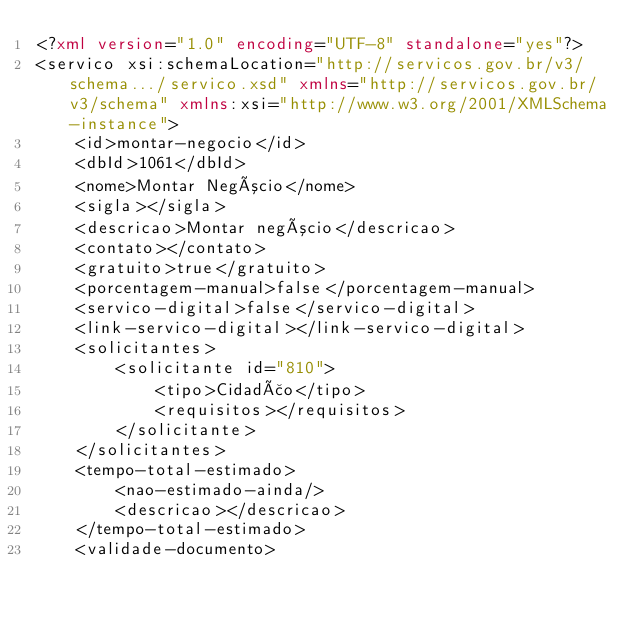<code> <loc_0><loc_0><loc_500><loc_500><_XML_><?xml version="1.0" encoding="UTF-8" standalone="yes"?>
<servico xsi:schemaLocation="http://servicos.gov.br/v3/schema.../servico.xsd" xmlns="http://servicos.gov.br/v3/schema" xmlns:xsi="http://www.w3.org/2001/XMLSchema-instance">
    <id>montar-negocio</id>
    <dbId>1061</dbId>
    <nome>Montar Negócio</nome>
    <sigla></sigla>
    <descricao>Montar negócio</descricao>
    <contato></contato>
    <gratuito>true</gratuito>
    <porcentagem-manual>false</porcentagem-manual>
    <servico-digital>false</servico-digital>
    <link-servico-digital></link-servico-digital>
    <solicitantes>
        <solicitante id="810">
            <tipo>Cidadão</tipo>
            <requisitos></requisitos>
        </solicitante>
    </solicitantes>
    <tempo-total-estimado>
        <nao-estimado-ainda/>
        <descricao></descricao>
    </tempo-total-estimado>
    <validade-documento></code> 